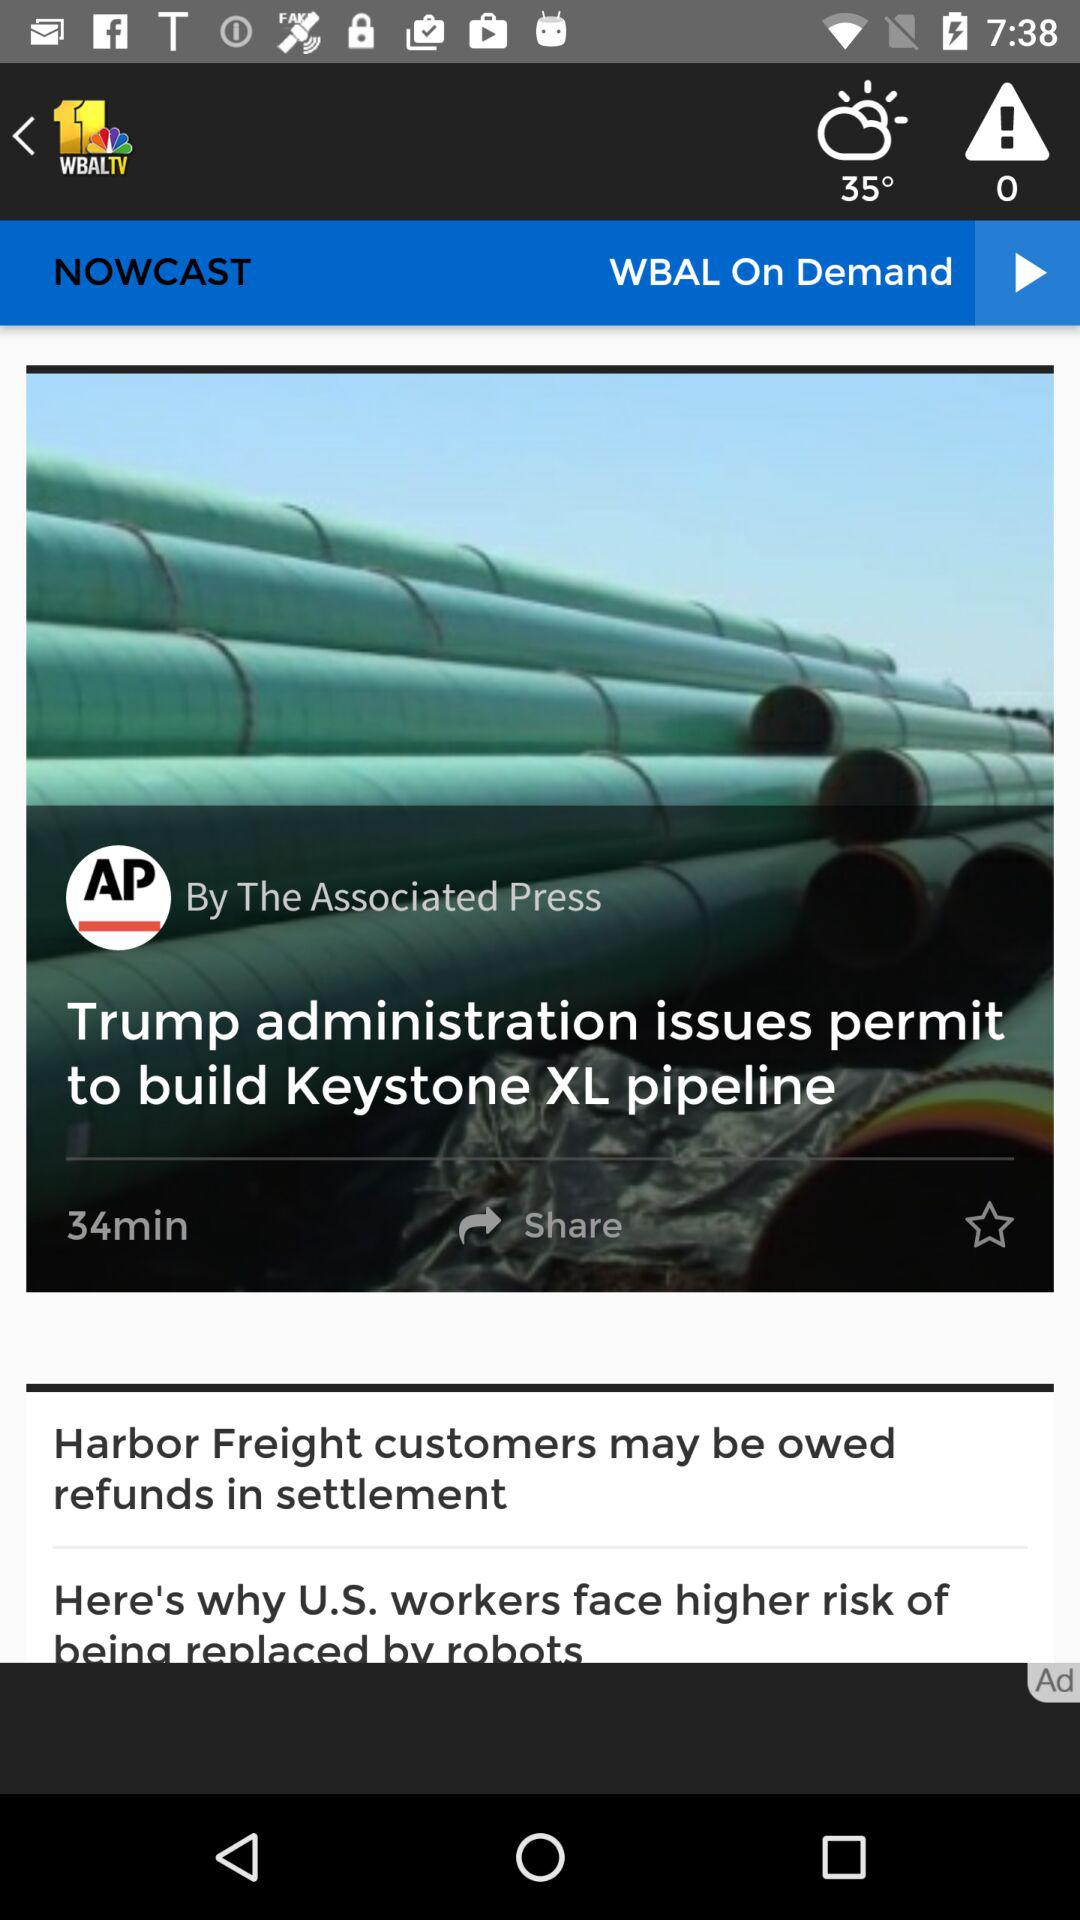How many degrees is the temperature shown on the screen? The temperature shown on the screen is 35°. 